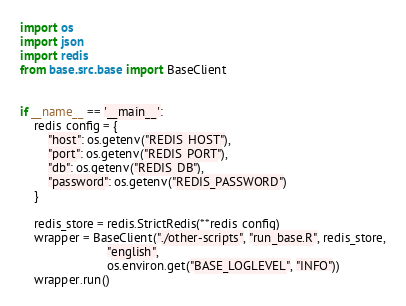Convert code to text. <code><loc_0><loc_0><loc_500><loc_500><_Python_>import os
import json
import redis
from base.src.base import BaseClient


if __name__ == '__main__':
    redis_config = {
        "host": os.getenv("REDIS_HOST"),
        "port": os.getenv("REDIS_PORT"),
        "db": os.getenv("REDIS_DB"),
        "password": os.getenv("REDIS_PASSWORD")
    }

    redis_store = redis.StrictRedis(**redis_config)
    wrapper = BaseClient("./other-scripts", "run_base.R", redis_store,
                         "english",
                         os.environ.get("BASE_LOGLEVEL", "INFO"))
    wrapper.run()
</code> 